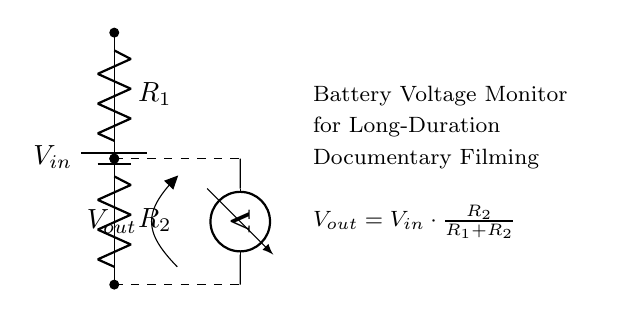What is the input voltage? The input voltage is represented as V_in in the circuit, but the actual value is not specified in the diagram.
Answer: V_in What are the resistor values? The circuit includes two resistors labeled R_1 and R_2, but the specific values for these resistors are not provided in the diagram.
Answer: R_1, R_2 What is the purpose of the voltmeter? The voltmeter is used to measure the output voltage across the resistors, providing a reading of the voltage at that specific point in the circuit.
Answer: Measure output voltage What is the output voltage formula? The output voltage V_out is calculated using the formula V_out = V_in * (R_2 / (R_1 + R_2)), which shows how it depends on both the input voltage and the resistor values.
Answer: V_out = V_in * (R_2 / (R_1 + R_2)) What happens to V_out if R_1 increases? If R_1 increases while R_2 remains constant, the output voltage V_out will decrease, as R_1 is in the denominator of the voltage divider formula, leading to a smaller fraction of V_in.
Answer: V_out decreases 